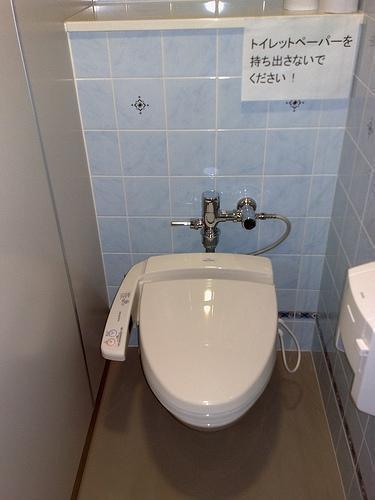How many toilet rolls are on the shelf?
Give a very brief answer. 2. How many circular buttons are there on the control panel?
Give a very brief answer. 2. 